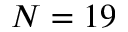Convert formula to latex. <formula><loc_0><loc_0><loc_500><loc_500>N = 1 9</formula> 